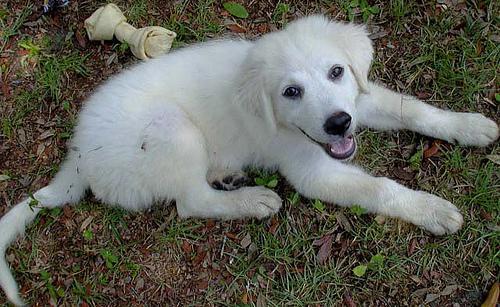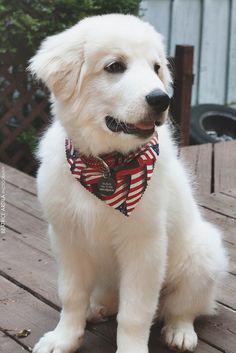The first image is the image on the left, the second image is the image on the right. Examine the images to the left and right. Is the description "The dog in the image on the left is lying on the grass." accurate? Answer yes or no. Yes. The first image is the image on the left, the second image is the image on the right. Assess this claim about the two images: "An image shows one white dog reclining on the grass with its front paws extended.". Correct or not? Answer yes or no. Yes. 